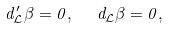<formula> <loc_0><loc_0><loc_500><loc_500>d _ { \mathcal { L } } ^ { \prime } \beta = 0 , \text { \ \ } d _ { \mathcal { L } } \beta = 0 ,</formula> 